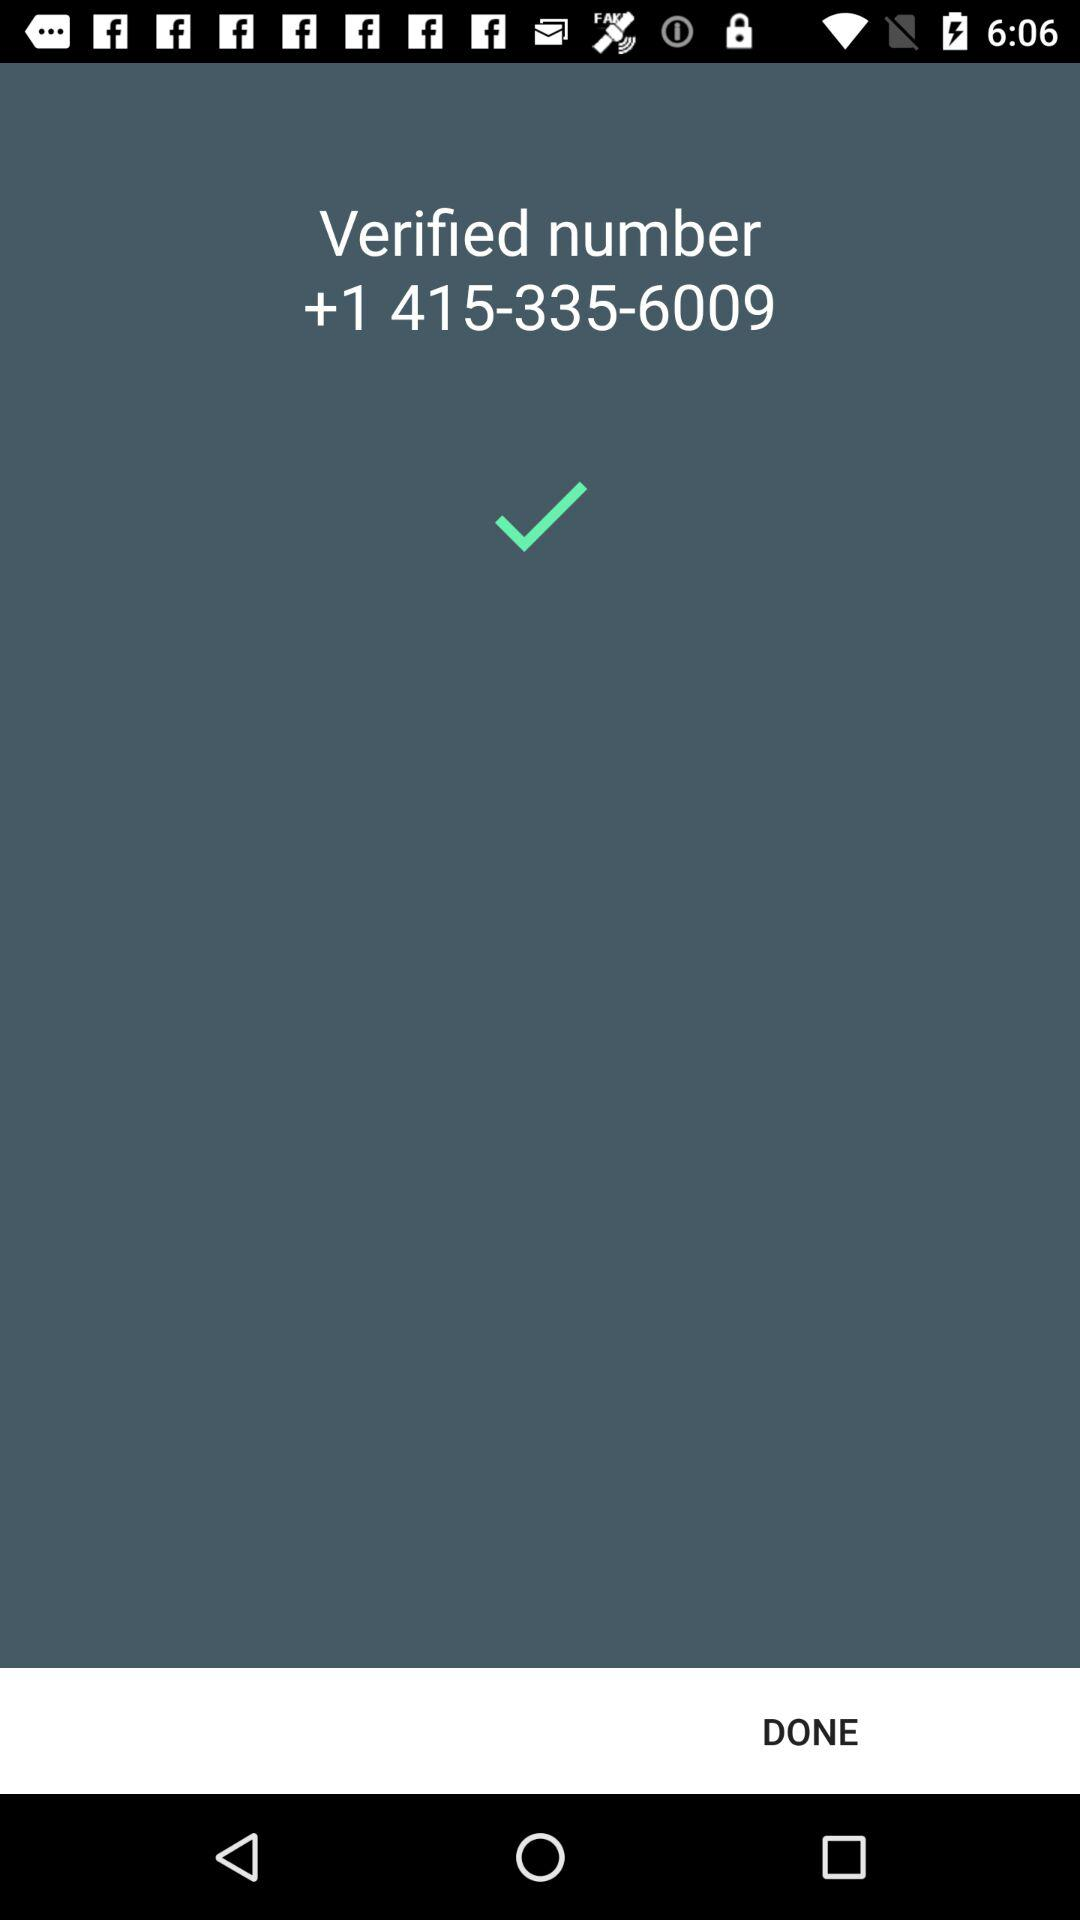What is the country code of the number? The country code is +1. 